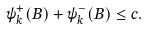Convert formula to latex. <formula><loc_0><loc_0><loc_500><loc_500>\psi _ { k } ^ { + } ( B ) + \psi _ { k } ^ { - } ( B ) \leq c .</formula> 